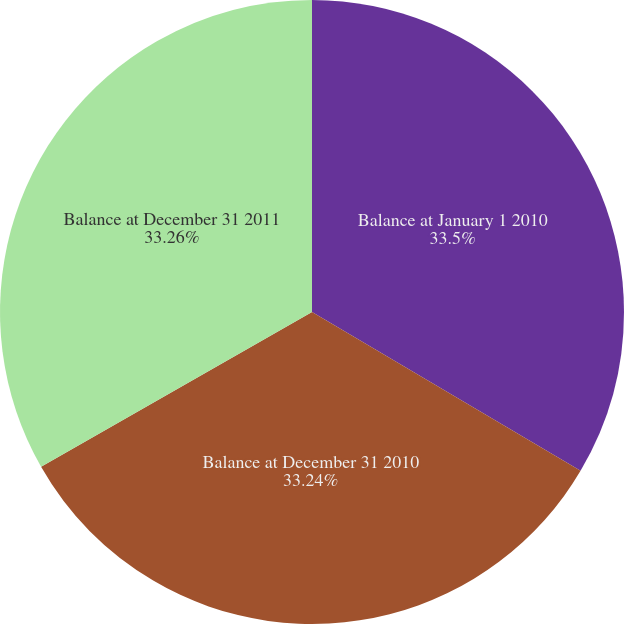Convert chart to OTSL. <chart><loc_0><loc_0><loc_500><loc_500><pie_chart><fcel>Balance at January 1 2010<fcel>Balance at December 31 2010<fcel>Balance at December 31 2011<nl><fcel>33.5%<fcel>33.24%<fcel>33.26%<nl></chart> 